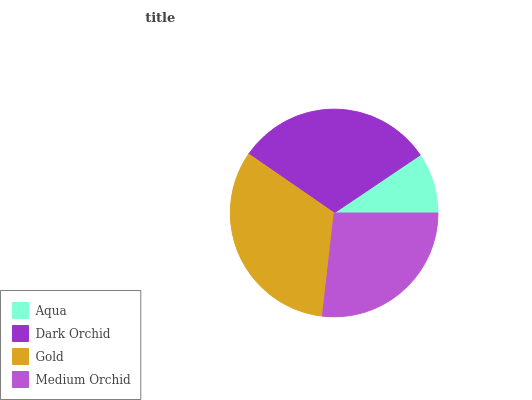Is Aqua the minimum?
Answer yes or no. Yes. Is Gold the maximum?
Answer yes or no. Yes. Is Dark Orchid the minimum?
Answer yes or no. No. Is Dark Orchid the maximum?
Answer yes or no. No. Is Dark Orchid greater than Aqua?
Answer yes or no. Yes. Is Aqua less than Dark Orchid?
Answer yes or no. Yes. Is Aqua greater than Dark Orchid?
Answer yes or no. No. Is Dark Orchid less than Aqua?
Answer yes or no. No. Is Dark Orchid the high median?
Answer yes or no. Yes. Is Medium Orchid the low median?
Answer yes or no. Yes. Is Medium Orchid the high median?
Answer yes or no. No. Is Gold the low median?
Answer yes or no. No. 